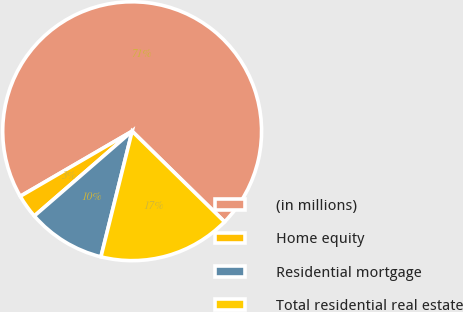Convert chart to OTSL. <chart><loc_0><loc_0><loc_500><loc_500><pie_chart><fcel>(in millions)<fcel>Home equity<fcel>Residential mortgage<fcel>Total residential real estate<nl><fcel>70.73%<fcel>2.98%<fcel>9.76%<fcel>16.53%<nl></chart> 